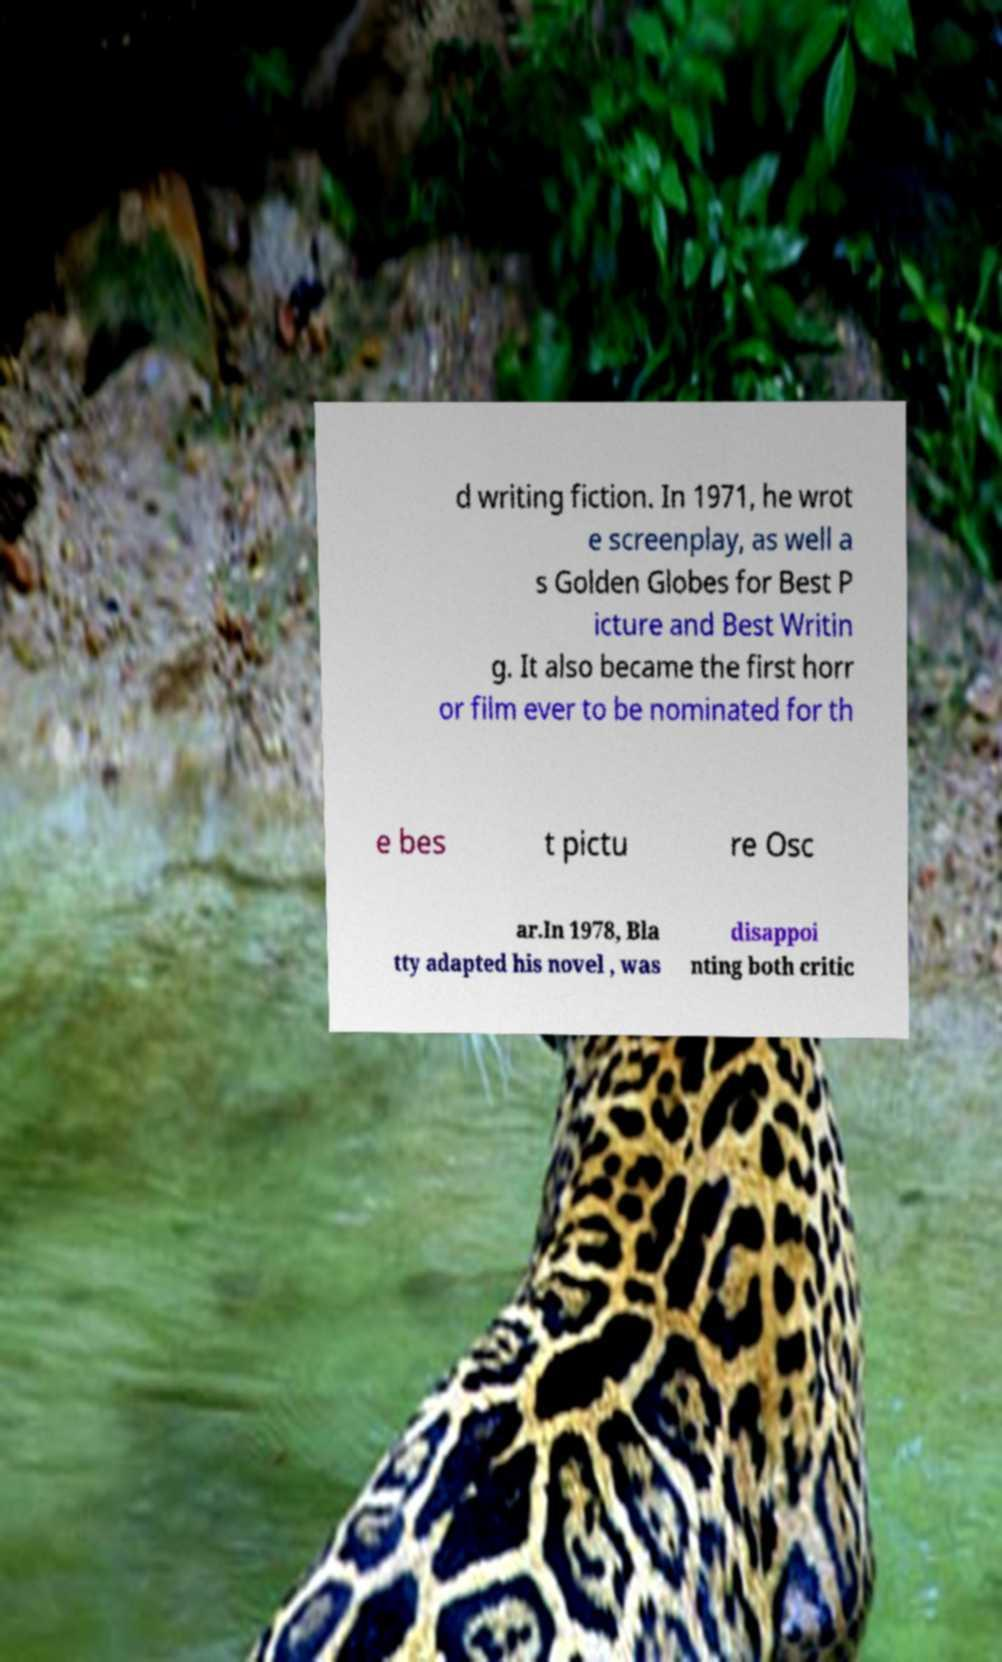Can you read and provide the text displayed in the image?This photo seems to have some interesting text. Can you extract and type it out for me? d writing fiction. In 1971, he wrot e screenplay, as well a s Golden Globes for Best P icture and Best Writin g. It also became the first horr or film ever to be nominated for th e bes t pictu re Osc ar.In 1978, Bla tty adapted his novel , was disappoi nting both critic 